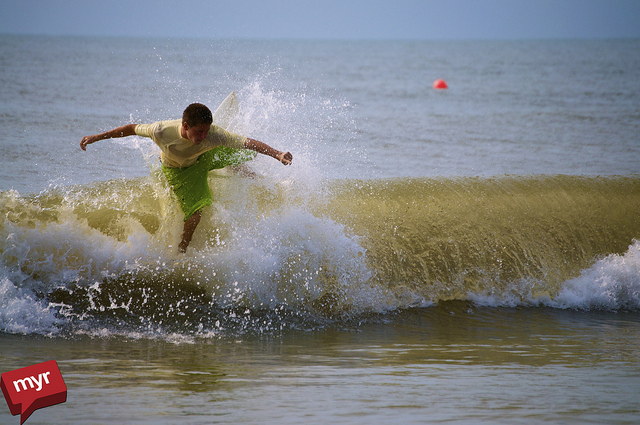Identify the text displayed in this image. myr 